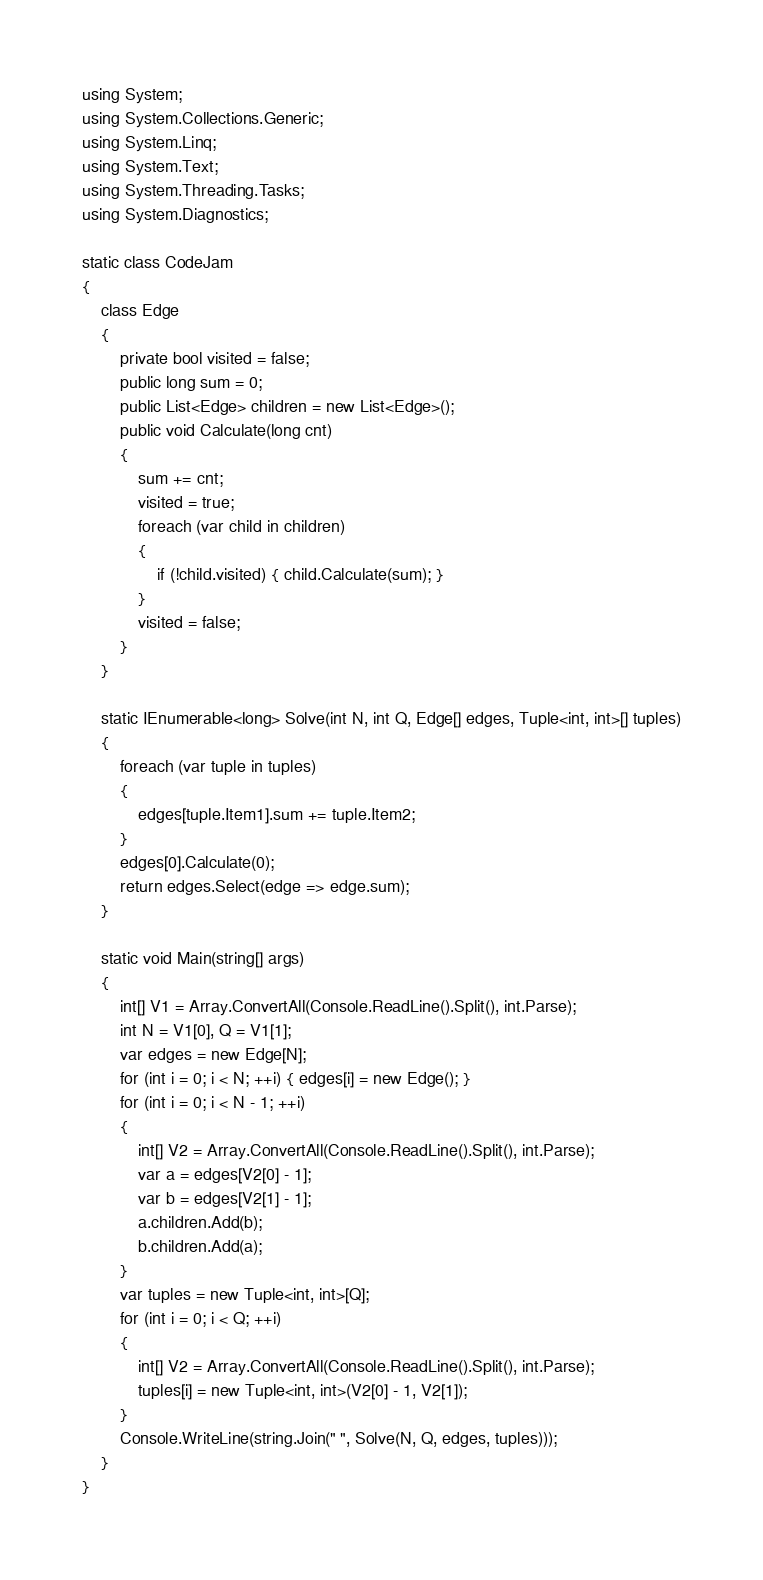Convert code to text. <code><loc_0><loc_0><loc_500><loc_500><_C#_>using System;
using System.Collections.Generic;
using System.Linq;
using System.Text;
using System.Threading.Tasks;
using System.Diagnostics;

static class CodeJam
{
    class Edge
    {
        private bool visited = false;
        public long sum = 0;
        public List<Edge> children = new List<Edge>();
        public void Calculate(long cnt)
        {
            sum += cnt;
            visited = true;
            foreach (var child in children)
            {
                if (!child.visited) { child.Calculate(sum); }
            }
            visited = false;
        }
    }

    static IEnumerable<long> Solve(int N, int Q, Edge[] edges, Tuple<int, int>[] tuples)
    {
        foreach (var tuple in tuples)
        {
            edges[tuple.Item1].sum += tuple.Item2;
        }
        edges[0].Calculate(0);
        return edges.Select(edge => edge.sum);
    }

    static void Main(string[] args)
    {
        int[] V1 = Array.ConvertAll(Console.ReadLine().Split(), int.Parse);
        int N = V1[0], Q = V1[1];
        var edges = new Edge[N];
        for (int i = 0; i < N; ++i) { edges[i] = new Edge(); }
        for (int i = 0; i < N - 1; ++i)
        {
            int[] V2 = Array.ConvertAll(Console.ReadLine().Split(), int.Parse);
            var a = edges[V2[0] - 1];
            var b = edges[V2[1] - 1];
            a.children.Add(b);
            b.children.Add(a);
        }
        var tuples = new Tuple<int, int>[Q];
        for (int i = 0; i < Q; ++i)
        {
            int[] V2 = Array.ConvertAll(Console.ReadLine().Split(), int.Parse);
            tuples[i] = new Tuple<int, int>(V2[0] - 1, V2[1]);
        }
        Console.WriteLine(string.Join(" ", Solve(N, Q, edges, tuples)));
    }
}
</code> 